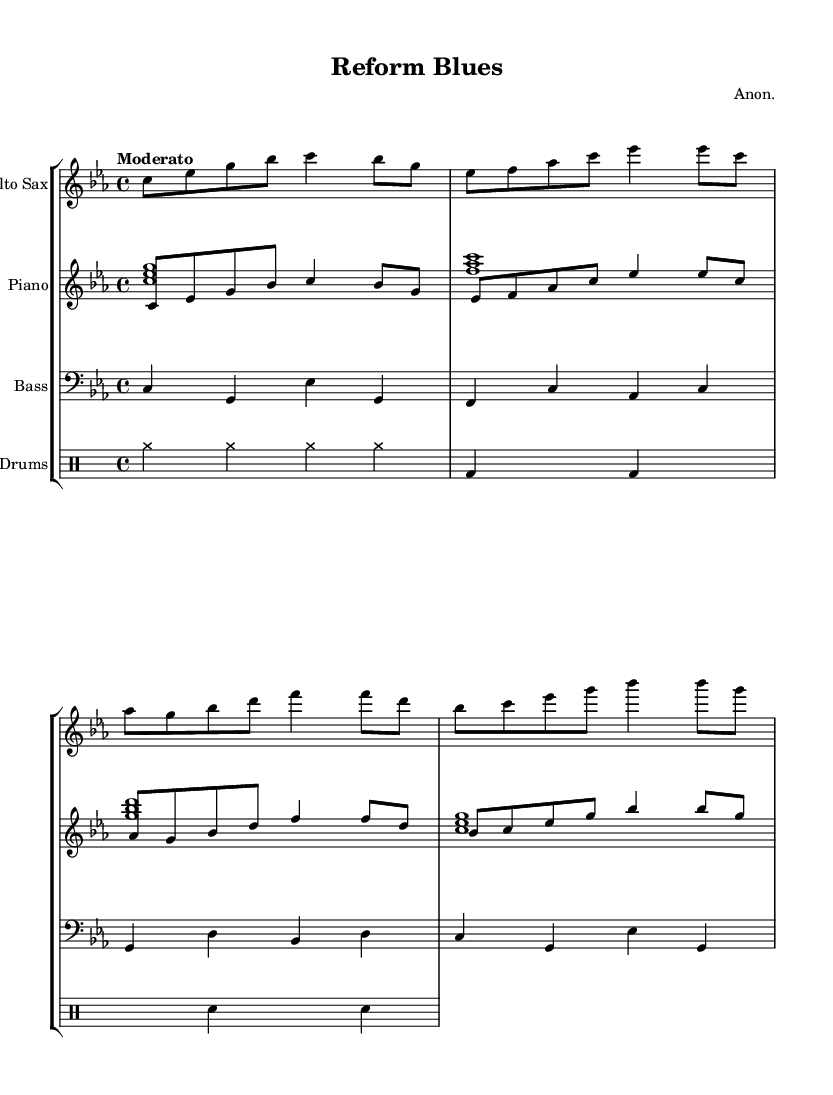What is the key signature of this music? The key signature displayed in the sheet music indicates C minor, which has three flats: B♭, E♭, and A♭.
Answer: C minor What is the time signature of the piece? The time signature, shown at the beginning of the music, is 4/4, meaning there are four beats in each measure and the quarter note gets one beat.
Answer: 4/4 What is the tempo marking for this composition? The tempo is noted as "Moderato," which implies a moderate pace, typically around 108 to 120 beats per minute.
Answer: Moderato How many measures are present in the saxophone part? Counting the measures in the saxophone line, there are a total of four distinct measures, each visually separated by bar lines.
Answer: 4 What type of jazz ensemble is represented in this composition? The sheet music features an ensemble consisting of an Alto Saxophone, Piano, Bass, and Drums, which is characteristic of a traditional jazz group.
Answer: Jazz quartet Which instrument plays the melody in this piece? The melody is indicated in the staff labeled for Alto Saxophone and is harmonized with the Piano chords in a secondary voice.
Answer: Alto Saxophone What is the role of the bass part in this composition? The bass part serves a foundational role, providing harmonic support and rhythmic stability throughout the piece, which is essential in jazz contexts.
Answer: Harmonic support 